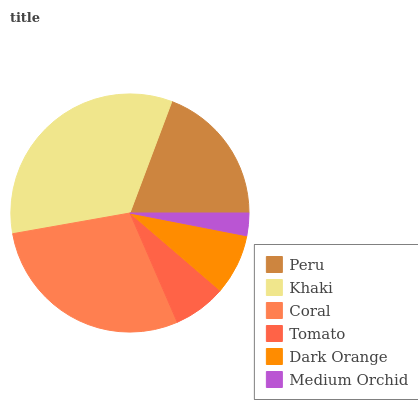Is Medium Orchid the minimum?
Answer yes or no. Yes. Is Khaki the maximum?
Answer yes or no. Yes. Is Coral the minimum?
Answer yes or no. No. Is Coral the maximum?
Answer yes or no. No. Is Khaki greater than Coral?
Answer yes or no. Yes. Is Coral less than Khaki?
Answer yes or no. Yes. Is Coral greater than Khaki?
Answer yes or no. No. Is Khaki less than Coral?
Answer yes or no. No. Is Peru the high median?
Answer yes or no. Yes. Is Dark Orange the low median?
Answer yes or no. Yes. Is Coral the high median?
Answer yes or no. No. Is Peru the low median?
Answer yes or no. No. 